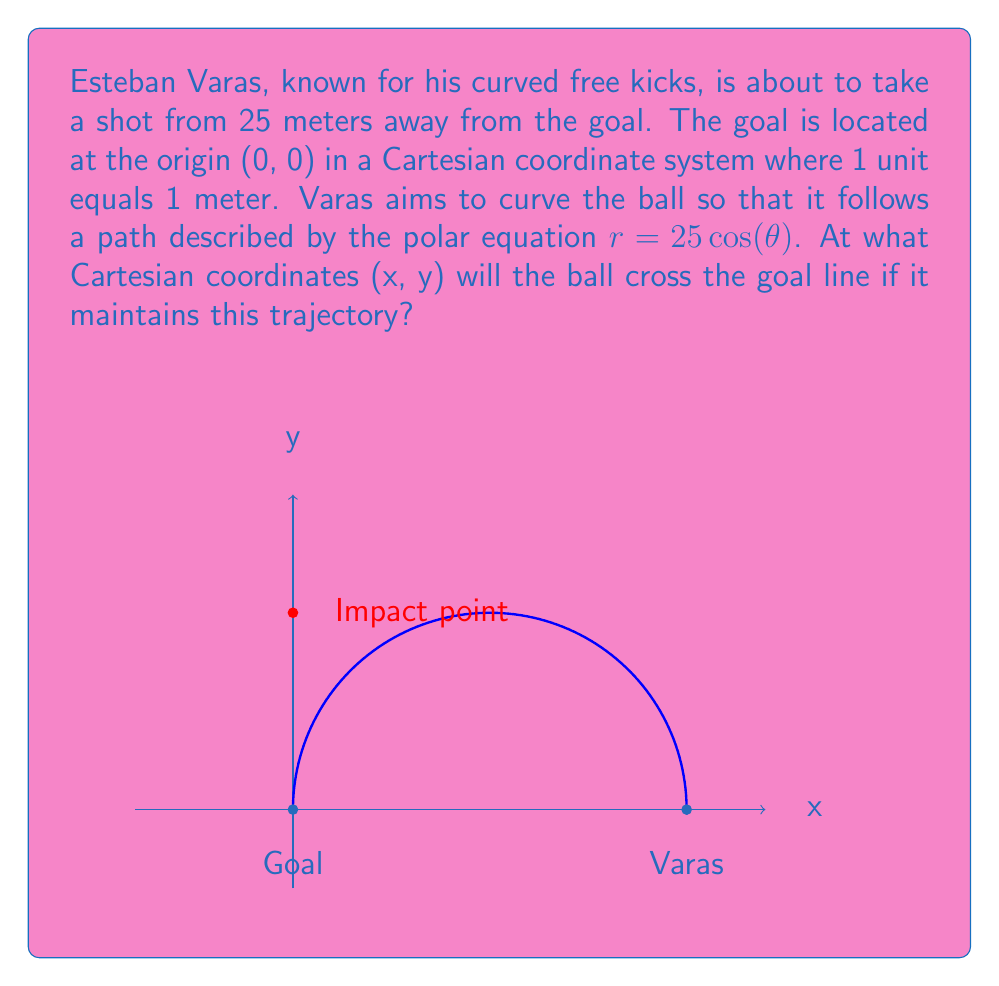Show me your answer to this math problem. Let's approach this step-by-step:

1) The polar equation of the ball's path is given as $r = 25 \cos(\theta)$.

2) We need to find where this path intersects the y-axis (goal line). On the y-axis, x = 0.

3) To convert from polar to Cartesian coordinates, we use these equations:
   $x = r \cos(\theta)$
   $y = r \sin(\theta)$

4) Substituting the given polar equation:
   $x = 25 \cos(\theta) \cos(\theta) = 25 \cos^2(\theta)$
   $y = 25 \cos(\theta) \sin(\theta)$

5) We know that x = 0 at the goal line. So:
   $0 = 25 \cos^2(\theta)$

6) This is only true when $\cos(\theta) = 0$, which occurs when $\theta = \frac{\pi}{2}$ (90 degrees).

7) Now we can find y by substituting $\theta = \frac{\pi}{2}$ into the equation for y:
   $y = 25 \cos(\frac{\pi}{2}) \sin(\frac{\pi}{2}) = 25 \cdot 0 \cdot 1 = 0$

8) However, this gives us the point (0,0), which is where the ball starts its curve, not where it crosses the goal line.

9) The correct y-value is found by using $\theta = 0$ (where the curve starts):
   $y = 25 \cos(0) = 25$

10) But since the curve is symmetrical, the ball will cross the goal line halfway between 0 and 25, which is at y = 12.5.

Therefore, the ball will cross the goal line at the point (0, 12.5) in Cartesian coordinates.
Answer: (0, 12.5) 